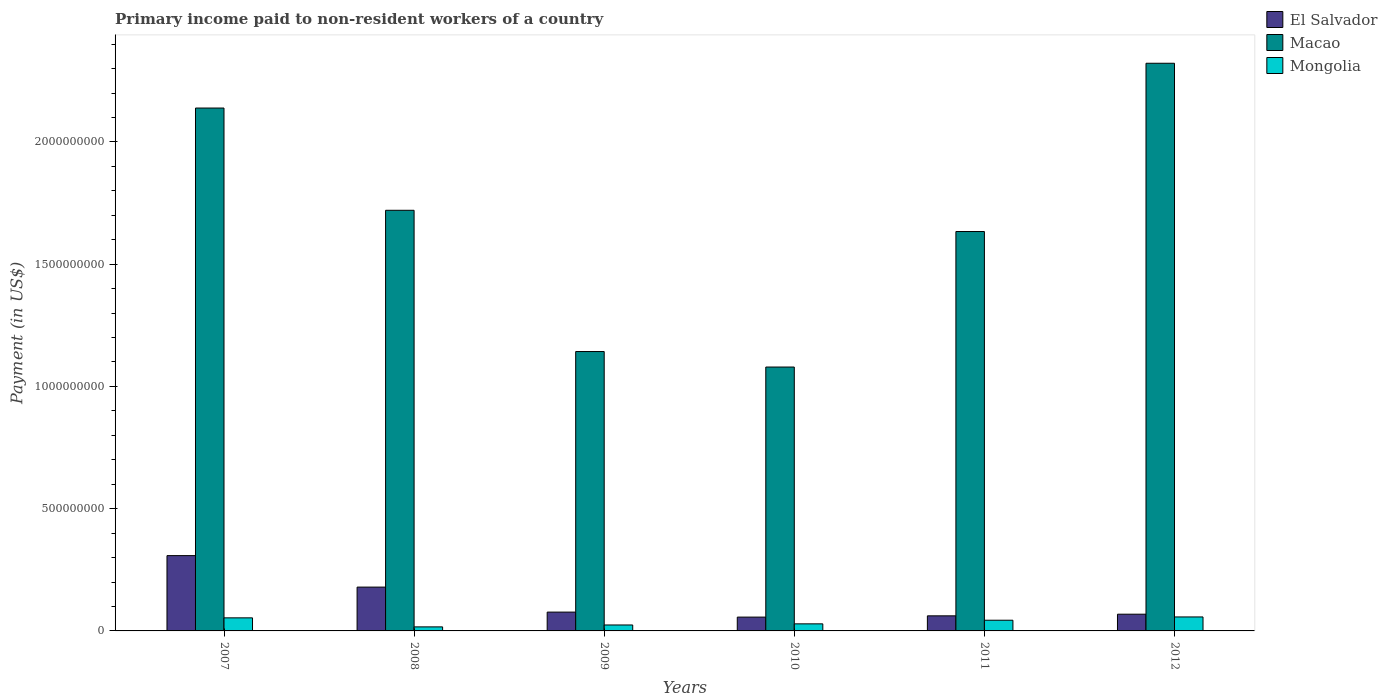How many different coloured bars are there?
Provide a succinct answer. 3. How many groups of bars are there?
Your answer should be very brief. 6. Are the number of bars per tick equal to the number of legend labels?
Your response must be concise. Yes. Are the number of bars on each tick of the X-axis equal?
Offer a terse response. Yes. How many bars are there on the 2nd tick from the left?
Ensure brevity in your answer.  3. In how many cases, is the number of bars for a given year not equal to the number of legend labels?
Your answer should be compact. 0. What is the amount paid to workers in El Salvador in 2008?
Your response must be concise. 1.79e+08. Across all years, what is the maximum amount paid to workers in El Salvador?
Keep it short and to the point. 3.08e+08. Across all years, what is the minimum amount paid to workers in Macao?
Your response must be concise. 1.08e+09. What is the total amount paid to workers in Mongolia in the graph?
Ensure brevity in your answer.  2.24e+08. What is the difference between the amount paid to workers in Mongolia in 2008 and that in 2010?
Your answer should be compact. -1.24e+07. What is the difference between the amount paid to workers in El Salvador in 2008 and the amount paid to workers in Mongolia in 2012?
Your response must be concise. 1.22e+08. What is the average amount paid to workers in El Salvador per year?
Your answer should be very brief. 1.25e+08. In the year 2011, what is the difference between the amount paid to workers in Macao and amount paid to workers in Mongolia?
Ensure brevity in your answer.  1.59e+09. What is the ratio of the amount paid to workers in Macao in 2007 to that in 2012?
Your response must be concise. 0.92. Is the amount paid to workers in Mongolia in 2008 less than that in 2011?
Your response must be concise. Yes. What is the difference between the highest and the second highest amount paid to workers in Macao?
Your response must be concise. 1.83e+08. What is the difference between the highest and the lowest amount paid to workers in Mongolia?
Your answer should be compact. 4.06e+07. In how many years, is the amount paid to workers in Mongolia greater than the average amount paid to workers in Mongolia taken over all years?
Your answer should be compact. 3. What does the 3rd bar from the left in 2007 represents?
Give a very brief answer. Mongolia. What does the 3rd bar from the right in 2012 represents?
Ensure brevity in your answer.  El Salvador. How many bars are there?
Your answer should be compact. 18. What is the difference between two consecutive major ticks on the Y-axis?
Keep it short and to the point. 5.00e+08. Does the graph contain any zero values?
Provide a short and direct response. No. Where does the legend appear in the graph?
Make the answer very short. Top right. How are the legend labels stacked?
Offer a terse response. Vertical. What is the title of the graph?
Provide a succinct answer. Primary income paid to non-resident workers of a country. Does "Latvia" appear as one of the legend labels in the graph?
Provide a short and direct response. No. What is the label or title of the X-axis?
Ensure brevity in your answer.  Years. What is the label or title of the Y-axis?
Offer a terse response. Payment (in US$). What is the Payment (in US$) in El Salvador in 2007?
Offer a terse response. 3.08e+08. What is the Payment (in US$) of Macao in 2007?
Your response must be concise. 2.14e+09. What is the Payment (in US$) of Mongolia in 2007?
Your answer should be compact. 5.35e+07. What is the Payment (in US$) of El Salvador in 2008?
Your answer should be compact. 1.79e+08. What is the Payment (in US$) of Macao in 2008?
Your answer should be very brief. 1.72e+09. What is the Payment (in US$) in Mongolia in 2008?
Make the answer very short. 1.65e+07. What is the Payment (in US$) of El Salvador in 2009?
Provide a short and direct response. 7.70e+07. What is the Payment (in US$) in Macao in 2009?
Offer a very short reply. 1.14e+09. What is the Payment (in US$) of Mongolia in 2009?
Your response must be concise. 2.43e+07. What is the Payment (in US$) in El Salvador in 2010?
Your response must be concise. 5.65e+07. What is the Payment (in US$) in Macao in 2010?
Ensure brevity in your answer.  1.08e+09. What is the Payment (in US$) in Mongolia in 2010?
Your answer should be very brief. 2.89e+07. What is the Payment (in US$) in El Salvador in 2011?
Your response must be concise. 6.17e+07. What is the Payment (in US$) of Macao in 2011?
Ensure brevity in your answer.  1.63e+09. What is the Payment (in US$) of Mongolia in 2011?
Your response must be concise. 4.37e+07. What is the Payment (in US$) in El Salvador in 2012?
Keep it short and to the point. 6.84e+07. What is the Payment (in US$) of Macao in 2012?
Give a very brief answer. 2.32e+09. What is the Payment (in US$) in Mongolia in 2012?
Keep it short and to the point. 5.72e+07. Across all years, what is the maximum Payment (in US$) of El Salvador?
Keep it short and to the point. 3.08e+08. Across all years, what is the maximum Payment (in US$) of Macao?
Your response must be concise. 2.32e+09. Across all years, what is the maximum Payment (in US$) in Mongolia?
Your response must be concise. 5.72e+07. Across all years, what is the minimum Payment (in US$) in El Salvador?
Make the answer very short. 5.65e+07. Across all years, what is the minimum Payment (in US$) in Macao?
Give a very brief answer. 1.08e+09. Across all years, what is the minimum Payment (in US$) of Mongolia?
Make the answer very short. 1.65e+07. What is the total Payment (in US$) of El Salvador in the graph?
Offer a terse response. 7.51e+08. What is the total Payment (in US$) in Macao in the graph?
Provide a short and direct response. 1.00e+1. What is the total Payment (in US$) of Mongolia in the graph?
Provide a succinct answer. 2.24e+08. What is the difference between the Payment (in US$) of El Salvador in 2007 and that in 2008?
Offer a very short reply. 1.29e+08. What is the difference between the Payment (in US$) of Macao in 2007 and that in 2008?
Your answer should be very brief. 4.18e+08. What is the difference between the Payment (in US$) of Mongolia in 2007 and that in 2008?
Keep it short and to the point. 3.69e+07. What is the difference between the Payment (in US$) in El Salvador in 2007 and that in 2009?
Offer a very short reply. 2.31e+08. What is the difference between the Payment (in US$) of Macao in 2007 and that in 2009?
Offer a very short reply. 9.96e+08. What is the difference between the Payment (in US$) in Mongolia in 2007 and that in 2009?
Provide a short and direct response. 2.91e+07. What is the difference between the Payment (in US$) of El Salvador in 2007 and that in 2010?
Provide a short and direct response. 2.52e+08. What is the difference between the Payment (in US$) of Macao in 2007 and that in 2010?
Your answer should be very brief. 1.06e+09. What is the difference between the Payment (in US$) in Mongolia in 2007 and that in 2010?
Your answer should be very brief. 2.45e+07. What is the difference between the Payment (in US$) in El Salvador in 2007 and that in 2011?
Your answer should be very brief. 2.46e+08. What is the difference between the Payment (in US$) in Macao in 2007 and that in 2011?
Make the answer very short. 5.05e+08. What is the difference between the Payment (in US$) of Mongolia in 2007 and that in 2011?
Make the answer very short. 9.72e+06. What is the difference between the Payment (in US$) in El Salvador in 2007 and that in 2012?
Offer a very short reply. 2.40e+08. What is the difference between the Payment (in US$) in Macao in 2007 and that in 2012?
Offer a terse response. -1.83e+08. What is the difference between the Payment (in US$) of Mongolia in 2007 and that in 2012?
Keep it short and to the point. -3.72e+06. What is the difference between the Payment (in US$) of El Salvador in 2008 and that in 2009?
Your answer should be very brief. 1.02e+08. What is the difference between the Payment (in US$) of Macao in 2008 and that in 2009?
Make the answer very short. 5.78e+08. What is the difference between the Payment (in US$) in Mongolia in 2008 and that in 2009?
Provide a succinct answer. -7.78e+06. What is the difference between the Payment (in US$) of El Salvador in 2008 and that in 2010?
Your answer should be very brief. 1.23e+08. What is the difference between the Payment (in US$) of Macao in 2008 and that in 2010?
Give a very brief answer. 6.41e+08. What is the difference between the Payment (in US$) in Mongolia in 2008 and that in 2010?
Provide a succinct answer. -1.24e+07. What is the difference between the Payment (in US$) in El Salvador in 2008 and that in 2011?
Your response must be concise. 1.18e+08. What is the difference between the Payment (in US$) in Macao in 2008 and that in 2011?
Provide a short and direct response. 8.69e+07. What is the difference between the Payment (in US$) in Mongolia in 2008 and that in 2011?
Provide a short and direct response. -2.72e+07. What is the difference between the Payment (in US$) of El Salvador in 2008 and that in 2012?
Give a very brief answer. 1.11e+08. What is the difference between the Payment (in US$) in Macao in 2008 and that in 2012?
Give a very brief answer. -6.01e+08. What is the difference between the Payment (in US$) of Mongolia in 2008 and that in 2012?
Offer a terse response. -4.06e+07. What is the difference between the Payment (in US$) in El Salvador in 2009 and that in 2010?
Your answer should be compact. 2.05e+07. What is the difference between the Payment (in US$) of Macao in 2009 and that in 2010?
Your response must be concise. 6.34e+07. What is the difference between the Payment (in US$) of Mongolia in 2009 and that in 2010?
Make the answer very short. -4.60e+06. What is the difference between the Payment (in US$) in El Salvador in 2009 and that in 2011?
Offer a terse response. 1.53e+07. What is the difference between the Payment (in US$) of Macao in 2009 and that in 2011?
Provide a succinct answer. -4.91e+08. What is the difference between the Payment (in US$) of Mongolia in 2009 and that in 2011?
Offer a very short reply. -1.94e+07. What is the difference between the Payment (in US$) of El Salvador in 2009 and that in 2012?
Your response must be concise. 8.58e+06. What is the difference between the Payment (in US$) of Macao in 2009 and that in 2012?
Keep it short and to the point. -1.18e+09. What is the difference between the Payment (in US$) in Mongolia in 2009 and that in 2012?
Provide a succinct answer. -3.29e+07. What is the difference between the Payment (in US$) in El Salvador in 2010 and that in 2011?
Give a very brief answer. -5.18e+06. What is the difference between the Payment (in US$) of Macao in 2010 and that in 2011?
Ensure brevity in your answer.  -5.54e+08. What is the difference between the Payment (in US$) of Mongolia in 2010 and that in 2011?
Your answer should be compact. -1.48e+07. What is the difference between the Payment (in US$) of El Salvador in 2010 and that in 2012?
Make the answer very short. -1.19e+07. What is the difference between the Payment (in US$) of Macao in 2010 and that in 2012?
Give a very brief answer. -1.24e+09. What is the difference between the Payment (in US$) of Mongolia in 2010 and that in 2012?
Offer a terse response. -2.83e+07. What is the difference between the Payment (in US$) of El Salvador in 2011 and that in 2012?
Provide a short and direct response. -6.70e+06. What is the difference between the Payment (in US$) of Macao in 2011 and that in 2012?
Your response must be concise. -6.88e+08. What is the difference between the Payment (in US$) of Mongolia in 2011 and that in 2012?
Make the answer very short. -1.34e+07. What is the difference between the Payment (in US$) of El Salvador in 2007 and the Payment (in US$) of Macao in 2008?
Your response must be concise. -1.41e+09. What is the difference between the Payment (in US$) in El Salvador in 2007 and the Payment (in US$) in Mongolia in 2008?
Make the answer very short. 2.91e+08. What is the difference between the Payment (in US$) in Macao in 2007 and the Payment (in US$) in Mongolia in 2008?
Your answer should be very brief. 2.12e+09. What is the difference between the Payment (in US$) in El Salvador in 2007 and the Payment (in US$) in Macao in 2009?
Your answer should be compact. -8.35e+08. What is the difference between the Payment (in US$) of El Salvador in 2007 and the Payment (in US$) of Mongolia in 2009?
Provide a short and direct response. 2.84e+08. What is the difference between the Payment (in US$) of Macao in 2007 and the Payment (in US$) of Mongolia in 2009?
Your answer should be very brief. 2.11e+09. What is the difference between the Payment (in US$) in El Salvador in 2007 and the Payment (in US$) in Macao in 2010?
Offer a very short reply. -7.71e+08. What is the difference between the Payment (in US$) of El Salvador in 2007 and the Payment (in US$) of Mongolia in 2010?
Provide a short and direct response. 2.79e+08. What is the difference between the Payment (in US$) in Macao in 2007 and the Payment (in US$) in Mongolia in 2010?
Your answer should be very brief. 2.11e+09. What is the difference between the Payment (in US$) in El Salvador in 2007 and the Payment (in US$) in Macao in 2011?
Give a very brief answer. -1.33e+09. What is the difference between the Payment (in US$) of El Salvador in 2007 and the Payment (in US$) of Mongolia in 2011?
Your answer should be compact. 2.64e+08. What is the difference between the Payment (in US$) of Macao in 2007 and the Payment (in US$) of Mongolia in 2011?
Keep it short and to the point. 2.09e+09. What is the difference between the Payment (in US$) of El Salvador in 2007 and the Payment (in US$) of Macao in 2012?
Your response must be concise. -2.01e+09. What is the difference between the Payment (in US$) of El Salvador in 2007 and the Payment (in US$) of Mongolia in 2012?
Your response must be concise. 2.51e+08. What is the difference between the Payment (in US$) in Macao in 2007 and the Payment (in US$) in Mongolia in 2012?
Ensure brevity in your answer.  2.08e+09. What is the difference between the Payment (in US$) in El Salvador in 2008 and the Payment (in US$) in Macao in 2009?
Offer a very short reply. -9.64e+08. What is the difference between the Payment (in US$) in El Salvador in 2008 and the Payment (in US$) in Mongolia in 2009?
Offer a terse response. 1.55e+08. What is the difference between the Payment (in US$) in Macao in 2008 and the Payment (in US$) in Mongolia in 2009?
Keep it short and to the point. 1.70e+09. What is the difference between the Payment (in US$) in El Salvador in 2008 and the Payment (in US$) in Macao in 2010?
Offer a very short reply. -9.00e+08. What is the difference between the Payment (in US$) of El Salvador in 2008 and the Payment (in US$) of Mongolia in 2010?
Keep it short and to the point. 1.50e+08. What is the difference between the Payment (in US$) in Macao in 2008 and the Payment (in US$) in Mongolia in 2010?
Keep it short and to the point. 1.69e+09. What is the difference between the Payment (in US$) in El Salvador in 2008 and the Payment (in US$) in Macao in 2011?
Make the answer very short. -1.45e+09. What is the difference between the Payment (in US$) in El Salvador in 2008 and the Payment (in US$) in Mongolia in 2011?
Offer a terse response. 1.36e+08. What is the difference between the Payment (in US$) in Macao in 2008 and the Payment (in US$) in Mongolia in 2011?
Offer a very short reply. 1.68e+09. What is the difference between the Payment (in US$) in El Salvador in 2008 and the Payment (in US$) in Macao in 2012?
Your answer should be very brief. -2.14e+09. What is the difference between the Payment (in US$) in El Salvador in 2008 and the Payment (in US$) in Mongolia in 2012?
Your answer should be very brief. 1.22e+08. What is the difference between the Payment (in US$) in Macao in 2008 and the Payment (in US$) in Mongolia in 2012?
Ensure brevity in your answer.  1.66e+09. What is the difference between the Payment (in US$) in El Salvador in 2009 and the Payment (in US$) in Macao in 2010?
Your answer should be compact. -1.00e+09. What is the difference between the Payment (in US$) in El Salvador in 2009 and the Payment (in US$) in Mongolia in 2010?
Your response must be concise. 4.81e+07. What is the difference between the Payment (in US$) of Macao in 2009 and the Payment (in US$) of Mongolia in 2010?
Make the answer very short. 1.11e+09. What is the difference between the Payment (in US$) in El Salvador in 2009 and the Payment (in US$) in Macao in 2011?
Make the answer very short. -1.56e+09. What is the difference between the Payment (in US$) of El Salvador in 2009 and the Payment (in US$) of Mongolia in 2011?
Your response must be concise. 3.32e+07. What is the difference between the Payment (in US$) of Macao in 2009 and the Payment (in US$) of Mongolia in 2011?
Your answer should be compact. 1.10e+09. What is the difference between the Payment (in US$) of El Salvador in 2009 and the Payment (in US$) of Macao in 2012?
Provide a succinct answer. -2.24e+09. What is the difference between the Payment (in US$) in El Salvador in 2009 and the Payment (in US$) in Mongolia in 2012?
Offer a terse response. 1.98e+07. What is the difference between the Payment (in US$) in Macao in 2009 and the Payment (in US$) in Mongolia in 2012?
Make the answer very short. 1.09e+09. What is the difference between the Payment (in US$) of El Salvador in 2010 and the Payment (in US$) of Macao in 2011?
Ensure brevity in your answer.  -1.58e+09. What is the difference between the Payment (in US$) in El Salvador in 2010 and the Payment (in US$) in Mongolia in 2011?
Offer a very short reply. 1.28e+07. What is the difference between the Payment (in US$) of Macao in 2010 and the Payment (in US$) of Mongolia in 2011?
Give a very brief answer. 1.04e+09. What is the difference between the Payment (in US$) in El Salvador in 2010 and the Payment (in US$) in Macao in 2012?
Give a very brief answer. -2.27e+09. What is the difference between the Payment (in US$) of El Salvador in 2010 and the Payment (in US$) of Mongolia in 2012?
Provide a short and direct response. -6.73e+05. What is the difference between the Payment (in US$) of Macao in 2010 and the Payment (in US$) of Mongolia in 2012?
Ensure brevity in your answer.  1.02e+09. What is the difference between the Payment (in US$) in El Salvador in 2011 and the Payment (in US$) in Macao in 2012?
Offer a very short reply. -2.26e+09. What is the difference between the Payment (in US$) of El Salvador in 2011 and the Payment (in US$) of Mongolia in 2012?
Make the answer very short. 4.51e+06. What is the difference between the Payment (in US$) in Macao in 2011 and the Payment (in US$) in Mongolia in 2012?
Provide a short and direct response. 1.58e+09. What is the average Payment (in US$) of El Salvador per year?
Your answer should be very brief. 1.25e+08. What is the average Payment (in US$) of Macao per year?
Your answer should be very brief. 1.67e+09. What is the average Payment (in US$) of Mongolia per year?
Provide a succinct answer. 3.74e+07. In the year 2007, what is the difference between the Payment (in US$) of El Salvador and Payment (in US$) of Macao?
Provide a succinct answer. -1.83e+09. In the year 2007, what is the difference between the Payment (in US$) of El Salvador and Payment (in US$) of Mongolia?
Your response must be concise. 2.55e+08. In the year 2007, what is the difference between the Payment (in US$) of Macao and Payment (in US$) of Mongolia?
Your answer should be compact. 2.09e+09. In the year 2008, what is the difference between the Payment (in US$) of El Salvador and Payment (in US$) of Macao?
Provide a short and direct response. -1.54e+09. In the year 2008, what is the difference between the Payment (in US$) of El Salvador and Payment (in US$) of Mongolia?
Your answer should be compact. 1.63e+08. In the year 2008, what is the difference between the Payment (in US$) in Macao and Payment (in US$) in Mongolia?
Your answer should be very brief. 1.70e+09. In the year 2009, what is the difference between the Payment (in US$) of El Salvador and Payment (in US$) of Macao?
Your answer should be compact. -1.07e+09. In the year 2009, what is the difference between the Payment (in US$) of El Salvador and Payment (in US$) of Mongolia?
Make the answer very short. 5.27e+07. In the year 2009, what is the difference between the Payment (in US$) of Macao and Payment (in US$) of Mongolia?
Your response must be concise. 1.12e+09. In the year 2010, what is the difference between the Payment (in US$) in El Salvador and Payment (in US$) in Macao?
Provide a succinct answer. -1.02e+09. In the year 2010, what is the difference between the Payment (in US$) in El Salvador and Payment (in US$) in Mongolia?
Make the answer very short. 2.76e+07. In the year 2010, what is the difference between the Payment (in US$) in Macao and Payment (in US$) in Mongolia?
Make the answer very short. 1.05e+09. In the year 2011, what is the difference between the Payment (in US$) in El Salvador and Payment (in US$) in Macao?
Your answer should be compact. -1.57e+09. In the year 2011, what is the difference between the Payment (in US$) in El Salvador and Payment (in US$) in Mongolia?
Ensure brevity in your answer.  1.80e+07. In the year 2011, what is the difference between the Payment (in US$) in Macao and Payment (in US$) in Mongolia?
Your answer should be very brief. 1.59e+09. In the year 2012, what is the difference between the Payment (in US$) in El Salvador and Payment (in US$) in Macao?
Provide a succinct answer. -2.25e+09. In the year 2012, what is the difference between the Payment (in US$) of El Salvador and Payment (in US$) of Mongolia?
Offer a terse response. 1.12e+07. In the year 2012, what is the difference between the Payment (in US$) in Macao and Payment (in US$) in Mongolia?
Ensure brevity in your answer.  2.26e+09. What is the ratio of the Payment (in US$) in El Salvador in 2007 to that in 2008?
Offer a very short reply. 1.72. What is the ratio of the Payment (in US$) in Macao in 2007 to that in 2008?
Your answer should be very brief. 1.24. What is the ratio of the Payment (in US$) in Mongolia in 2007 to that in 2008?
Offer a very short reply. 3.23. What is the ratio of the Payment (in US$) in El Salvador in 2007 to that in 2009?
Offer a terse response. 4. What is the ratio of the Payment (in US$) in Macao in 2007 to that in 2009?
Ensure brevity in your answer.  1.87. What is the ratio of the Payment (in US$) of Mongolia in 2007 to that in 2009?
Your answer should be very brief. 2.2. What is the ratio of the Payment (in US$) in El Salvador in 2007 to that in 2010?
Offer a terse response. 5.45. What is the ratio of the Payment (in US$) in Macao in 2007 to that in 2010?
Your answer should be very brief. 1.98. What is the ratio of the Payment (in US$) of Mongolia in 2007 to that in 2010?
Ensure brevity in your answer.  1.85. What is the ratio of the Payment (in US$) in El Salvador in 2007 to that in 2011?
Offer a very short reply. 4.99. What is the ratio of the Payment (in US$) of Macao in 2007 to that in 2011?
Your answer should be compact. 1.31. What is the ratio of the Payment (in US$) of Mongolia in 2007 to that in 2011?
Provide a succinct answer. 1.22. What is the ratio of the Payment (in US$) of El Salvador in 2007 to that in 2012?
Your response must be concise. 4.5. What is the ratio of the Payment (in US$) of Macao in 2007 to that in 2012?
Offer a very short reply. 0.92. What is the ratio of the Payment (in US$) of Mongolia in 2007 to that in 2012?
Give a very brief answer. 0.93. What is the ratio of the Payment (in US$) in El Salvador in 2008 to that in 2009?
Give a very brief answer. 2.33. What is the ratio of the Payment (in US$) of Macao in 2008 to that in 2009?
Your answer should be very brief. 1.51. What is the ratio of the Payment (in US$) in Mongolia in 2008 to that in 2009?
Give a very brief answer. 0.68. What is the ratio of the Payment (in US$) in El Salvador in 2008 to that in 2010?
Offer a very short reply. 3.17. What is the ratio of the Payment (in US$) in Macao in 2008 to that in 2010?
Make the answer very short. 1.59. What is the ratio of the Payment (in US$) of Mongolia in 2008 to that in 2010?
Keep it short and to the point. 0.57. What is the ratio of the Payment (in US$) in El Salvador in 2008 to that in 2011?
Your answer should be compact. 2.91. What is the ratio of the Payment (in US$) of Macao in 2008 to that in 2011?
Ensure brevity in your answer.  1.05. What is the ratio of the Payment (in US$) of Mongolia in 2008 to that in 2011?
Make the answer very short. 0.38. What is the ratio of the Payment (in US$) in El Salvador in 2008 to that in 2012?
Your answer should be very brief. 2.62. What is the ratio of the Payment (in US$) in Macao in 2008 to that in 2012?
Offer a terse response. 0.74. What is the ratio of the Payment (in US$) in Mongolia in 2008 to that in 2012?
Give a very brief answer. 0.29. What is the ratio of the Payment (in US$) in El Salvador in 2009 to that in 2010?
Your answer should be very brief. 1.36. What is the ratio of the Payment (in US$) of Macao in 2009 to that in 2010?
Keep it short and to the point. 1.06. What is the ratio of the Payment (in US$) of Mongolia in 2009 to that in 2010?
Make the answer very short. 0.84. What is the ratio of the Payment (in US$) of El Salvador in 2009 to that in 2011?
Keep it short and to the point. 1.25. What is the ratio of the Payment (in US$) in Macao in 2009 to that in 2011?
Your answer should be compact. 0.7. What is the ratio of the Payment (in US$) of Mongolia in 2009 to that in 2011?
Your response must be concise. 0.56. What is the ratio of the Payment (in US$) in El Salvador in 2009 to that in 2012?
Make the answer very short. 1.13. What is the ratio of the Payment (in US$) of Macao in 2009 to that in 2012?
Give a very brief answer. 0.49. What is the ratio of the Payment (in US$) in Mongolia in 2009 to that in 2012?
Make the answer very short. 0.43. What is the ratio of the Payment (in US$) of El Salvador in 2010 to that in 2011?
Your answer should be very brief. 0.92. What is the ratio of the Payment (in US$) in Macao in 2010 to that in 2011?
Provide a short and direct response. 0.66. What is the ratio of the Payment (in US$) in Mongolia in 2010 to that in 2011?
Offer a very short reply. 0.66. What is the ratio of the Payment (in US$) of El Salvador in 2010 to that in 2012?
Offer a very short reply. 0.83. What is the ratio of the Payment (in US$) in Macao in 2010 to that in 2012?
Provide a succinct answer. 0.46. What is the ratio of the Payment (in US$) in Mongolia in 2010 to that in 2012?
Provide a short and direct response. 0.51. What is the ratio of the Payment (in US$) in El Salvador in 2011 to that in 2012?
Give a very brief answer. 0.9. What is the ratio of the Payment (in US$) in Macao in 2011 to that in 2012?
Offer a terse response. 0.7. What is the ratio of the Payment (in US$) of Mongolia in 2011 to that in 2012?
Give a very brief answer. 0.76. What is the difference between the highest and the second highest Payment (in US$) of El Salvador?
Ensure brevity in your answer.  1.29e+08. What is the difference between the highest and the second highest Payment (in US$) in Macao?
Offer a very short reply. 1.83e+08. What is the difference between the highest and the second highest Payment (in US$) of Mongolia?
Offer a very short reply. 3.72e+06. What is the difference between the highest and the lowest Payment (in US$) of El Salvador?
Make the answer very short. 2.52e+08. What is the difference between the highest and the lowest Payment (in US$) of Macao?
Provide a short and direct response. 1.24e+09. What is the difference between the highest and the lowest Payment (in US$) in Mongolia?
Your response must be concise. 4.06e+07. 